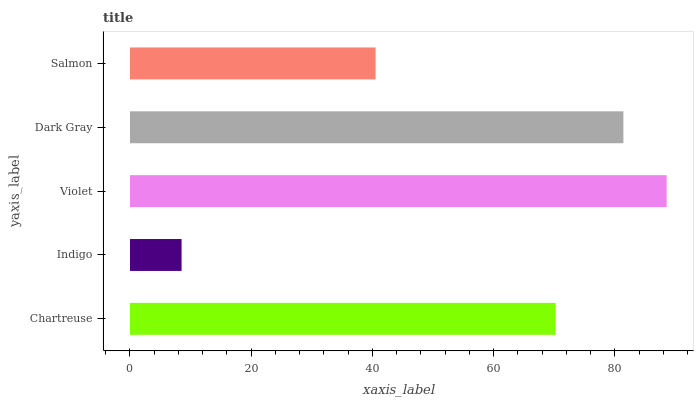Is Indigo the minimum?
Answer yes or no. Yes. Is Violet the maximum?
Answer yes or no. Yes. Is Violet the minimum?
Answer yes or no. No. Is Indigo the maximum?
Answer yes or no. No. Is Violet greater than Indigo?
Answer yes or no. Yes. Is Indigo less than Violet?
Answer yes or no. Yes. Is Indigo greater than Violet?
Answer yes or no. No. Is Violet less than Indigo?
Answer yes or no. No. Is Chartreuse the high median?
Answer yes or no. Yes. Is Chartreuse the low median?
Answer yes or no. Yes. Is Salmon the high median?
Answer yes or no. No. Is Salmon the low median?
Answer yes or no. No. 